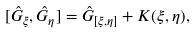<formula> <loc_0><loc_0><loc_500><loc_500>[ \hat { G } _ { \xi } , \hat { G } _ { \eta } ] = \hat { G } _ { [ \xi , \eta ] } + K ( \xi , \eta ) ,</formula> 